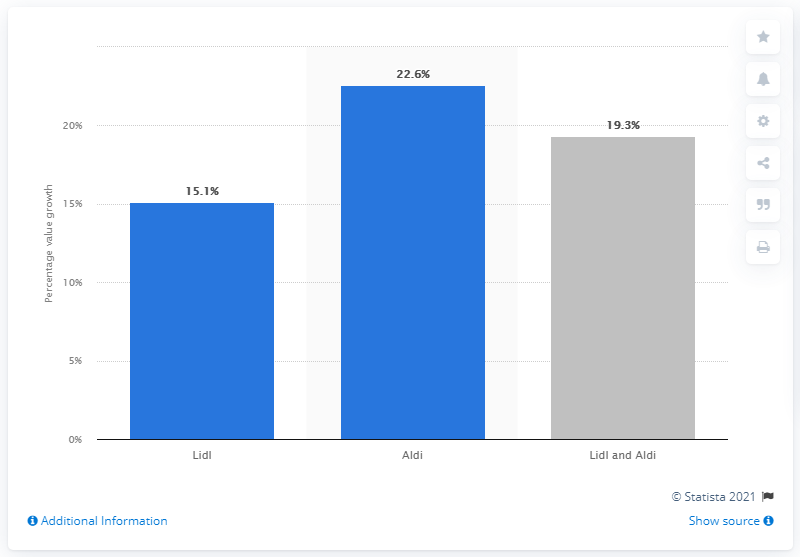Highlight a few significant elements in this photo. Aldi's value growth for the period compared to the same period a year earlier was 22.6%. 